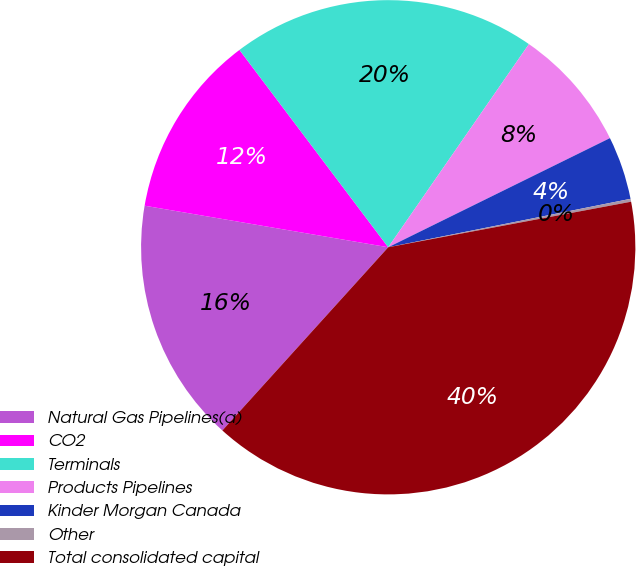<chart> <loc_0><loc_0><loc_500><loc_500><pie_chart><fcel>Natural Gas Pipelines(a)<fcel>CO2<fcel>Terminals<fcel>Products Pipelines<fcel>Kinder Morgan Canada<fcel>Other<fcel>Total consolidated capital<nl><fcel>15.98%<fcel>12.03%<fcel>19.92%<fcel>8.08%<fcel>4.14%<fcel>0.19%<fcel>39.66%<nl></chart> 